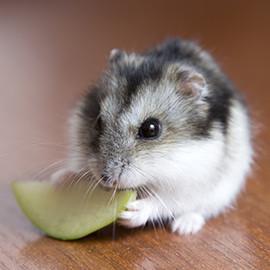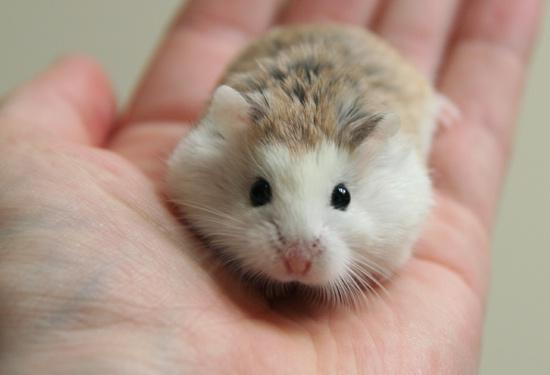The first image is the image on the left, the second image is the image on the right. For the images shown, is this caption "Two rodents in one of the images are face to face." true? Answer yes or no. No. The first image is the image on the left, the second image is the image on the right. Assess this claim about the two images: "An image shows exactly one pet rodent nibbling on a greenish tinged produce item.". Correct or not? Answer yes or no. Yes. 